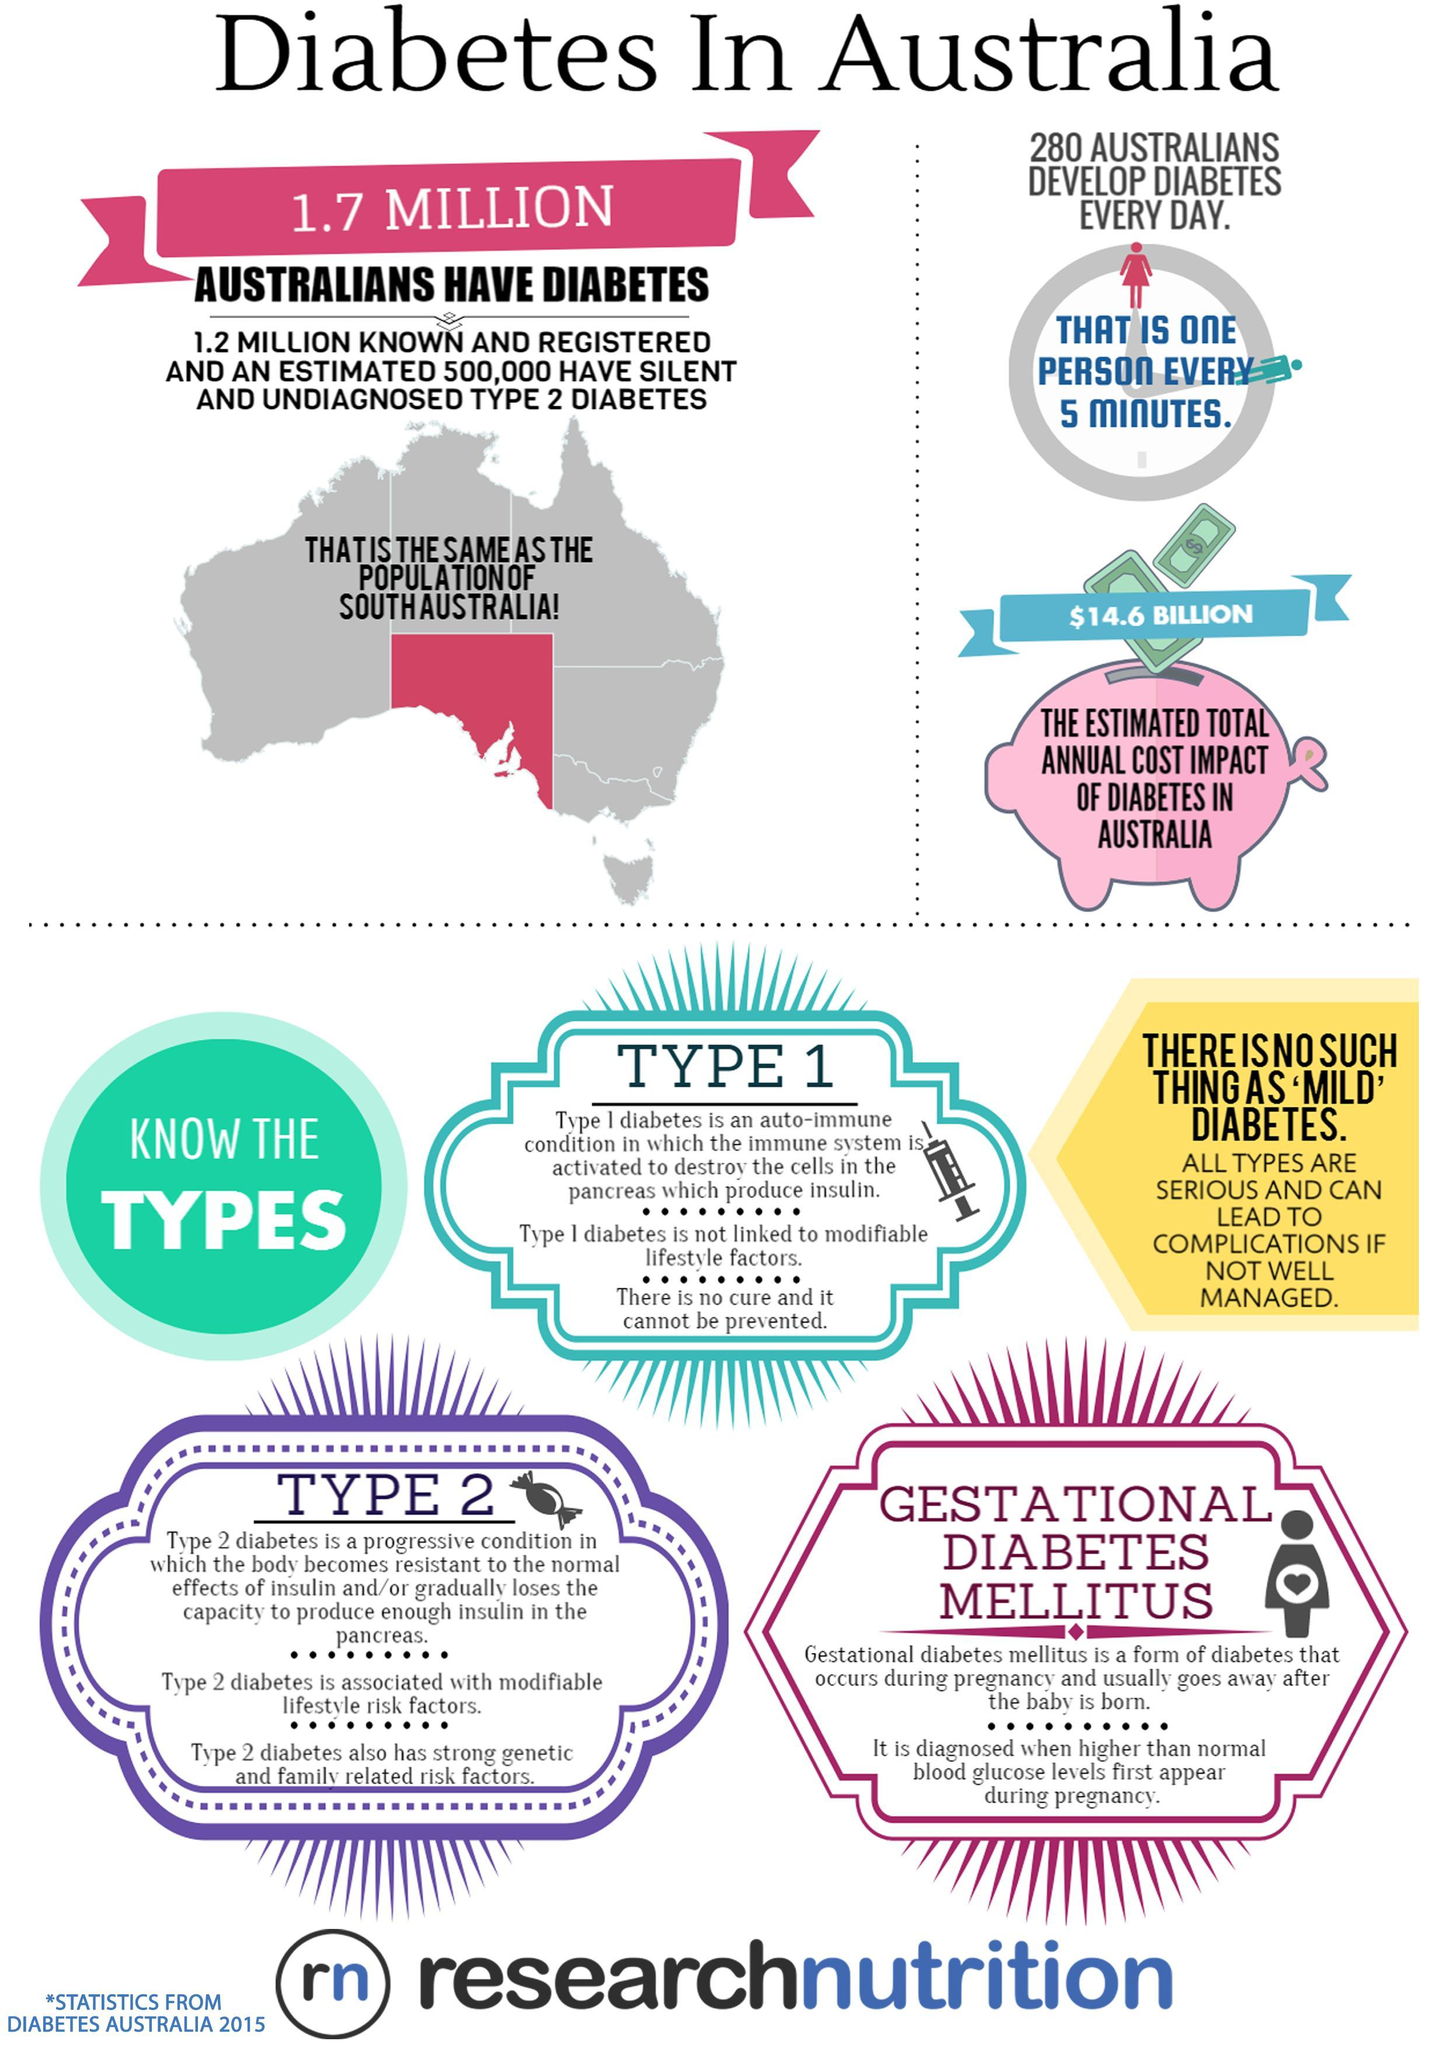How many types of Diabetes are listed ?
Answer the question with a short phrase. 3 